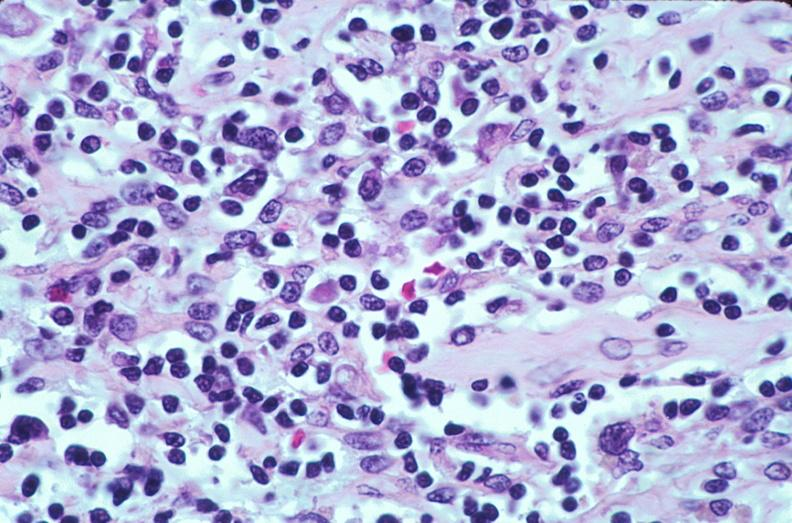does size show lymph nodes, nodular sclerosing hodgkins disease?
Answer the question using a single word or phrase. No 